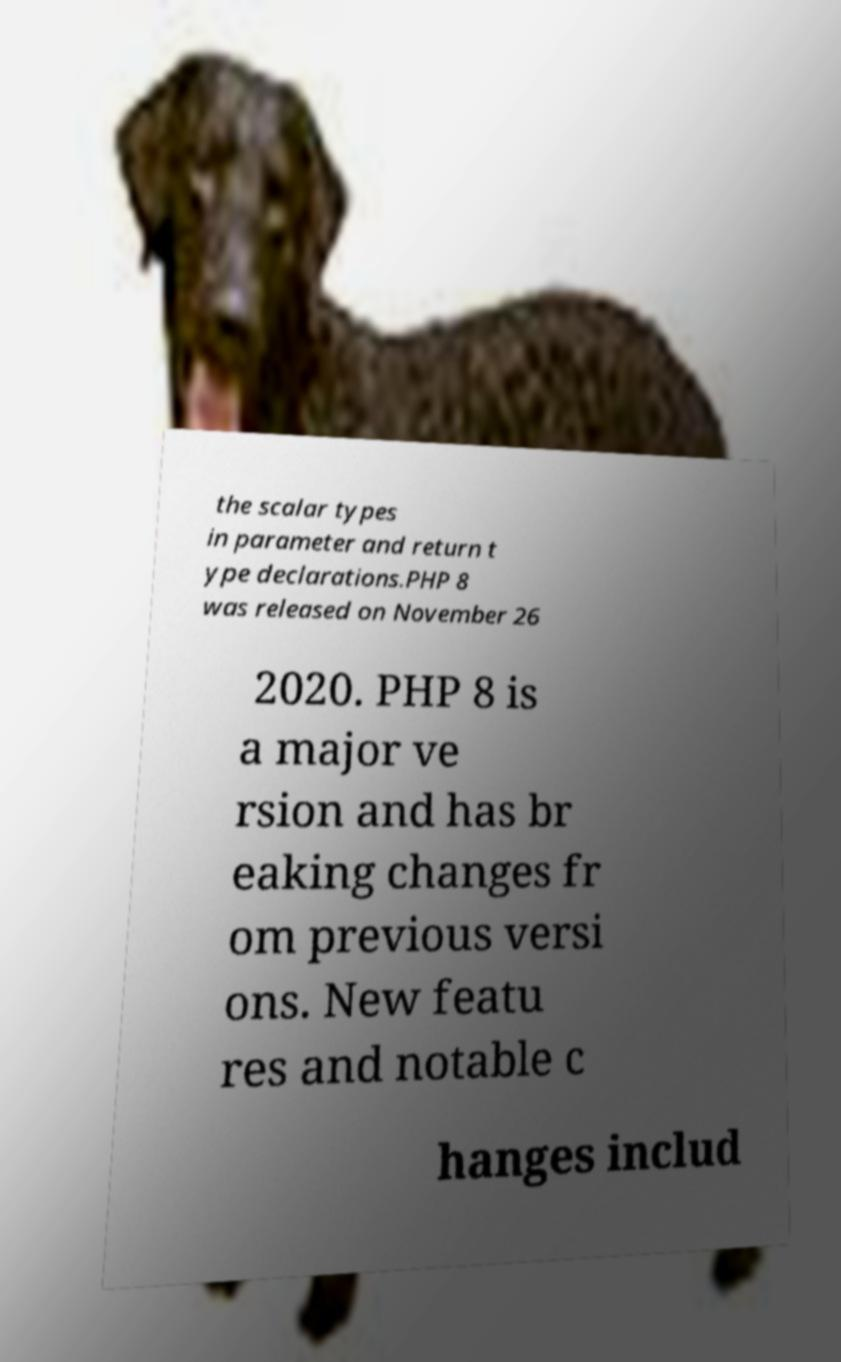Could you extract and type out the text from this image? the scalar types in parameter and return t ype declarations.PHP 8 was released on November 26 2020. PHP 8 is a major ve rsion and has br eaking changes fr om previous versi ons. New featu res and notable c hanges includ 